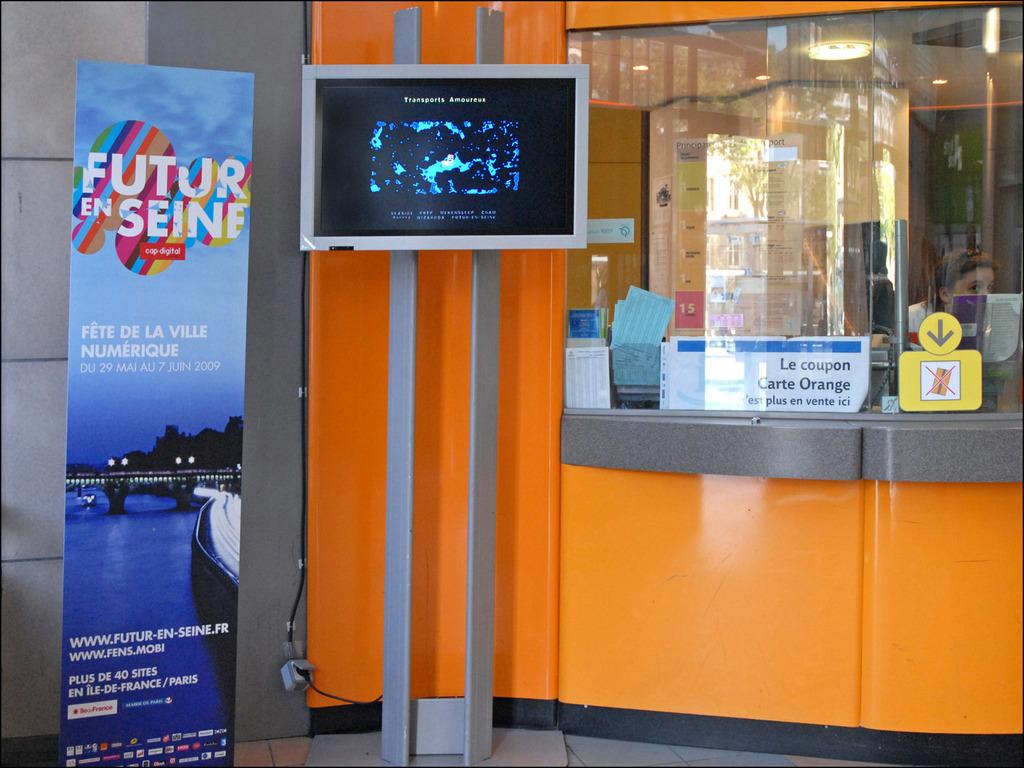What does the banner on the left say?
Offer a terse response. Futur en seine. 